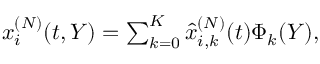<formula> <loc_0><loc_0><loc_500><loc_500>\begin{array} { r } { x _ { i } ^ { ( N ) } ( t , Y ) = \sum _ { k = 0 } ^ { K } \hat { x } _ { i , k } ^ { ( N ) } ( t ) \Phi _ { k } ( Y ) , } \end{array}</formula> 